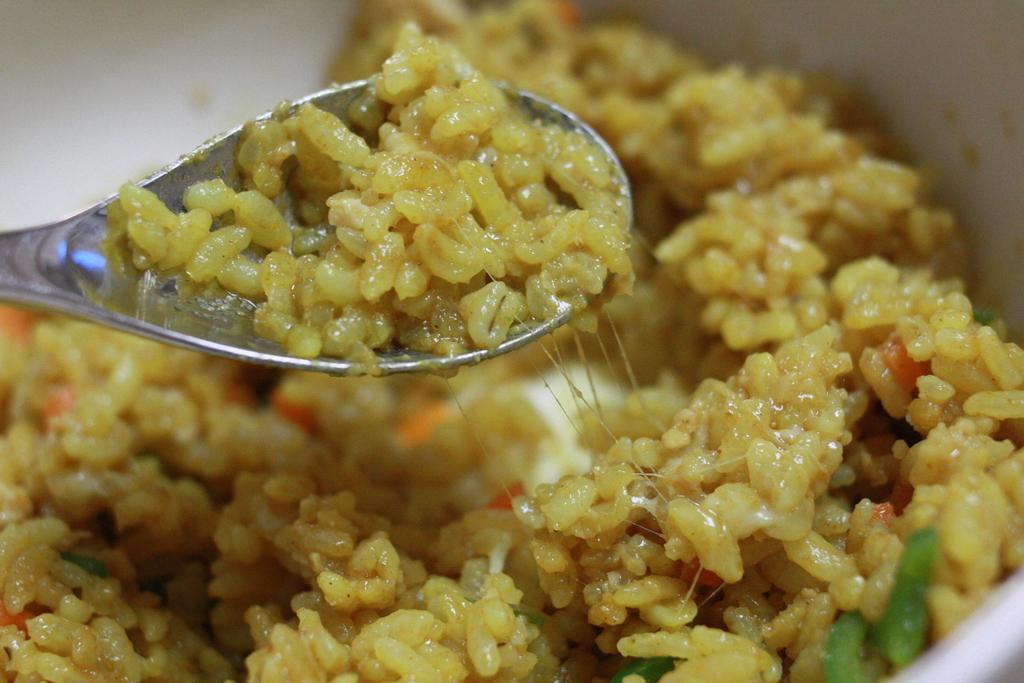What is the main object in the center of the image? There is a white color object in the center of the image. What can be found inside the object? The object contains a food item. Where is another food item located in the image? There is a food item in a spoon on the left side of the image. How many pets are visible in the image? There are no pets visible in the image. What type of account is associated with the food item in the image? There is no account associated with the food item in the image. 